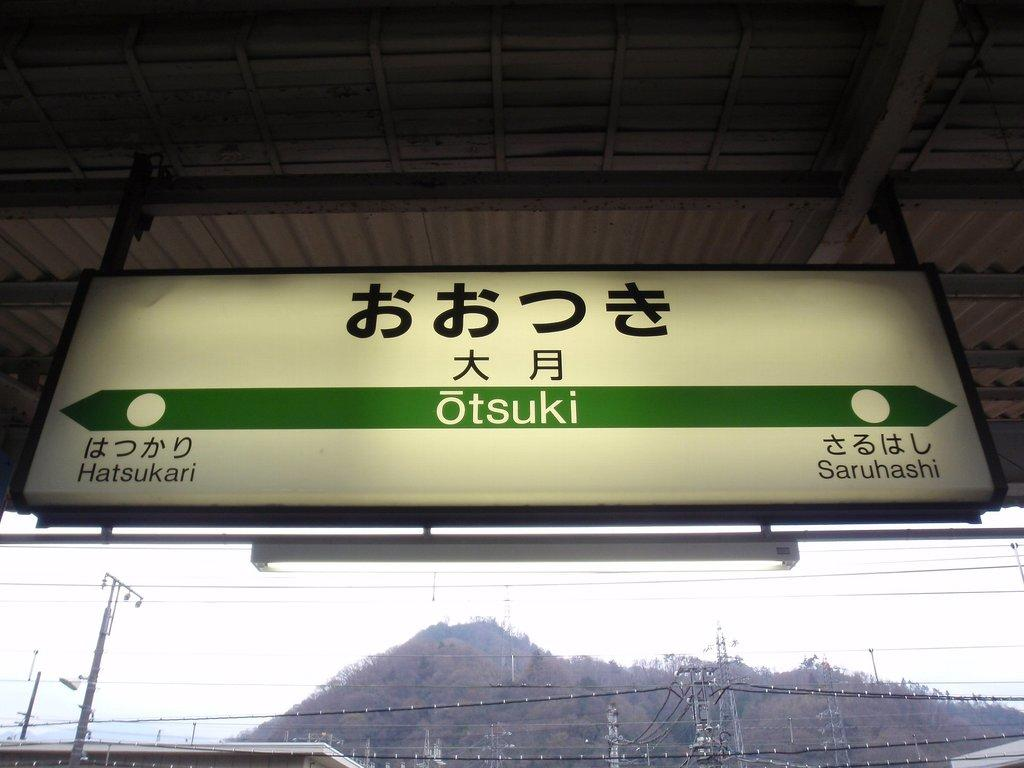<image>
Relay a brief, clear account of the picture shown. a otsuki travel sign with directions to hatsukari or saruhashi 